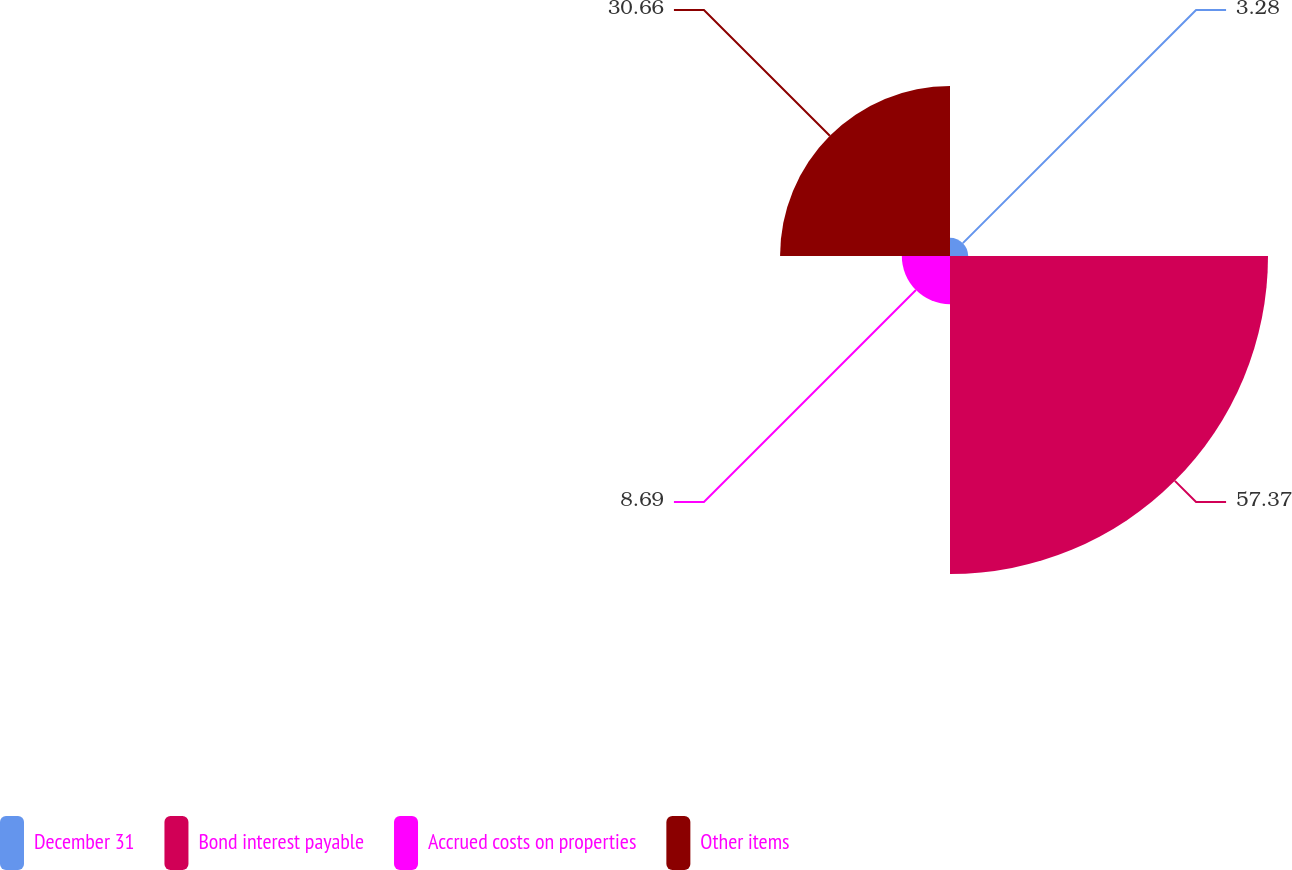Convert chart to OTSL. <chart><loc_0><loc_0><loc_500><loc_500><pie_chart><fcel>December 31<fcel>Bond interest payable<fcel>Accrued costs on properties<fcel>Other items<nl><fcel>3.28%<fcel>57.37%<fcel>8.69%<fcel>30.66%<nl></chart> 